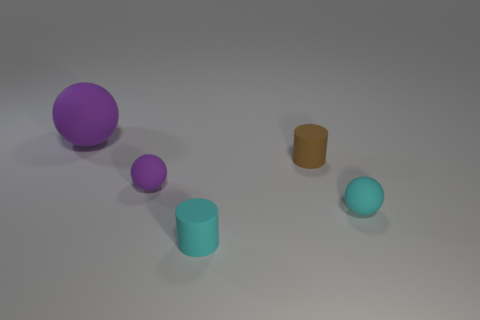How many objects are there in total, regardless of color? There are a total of five objects in the image, comprising both spherical and cylindrical shapes. 